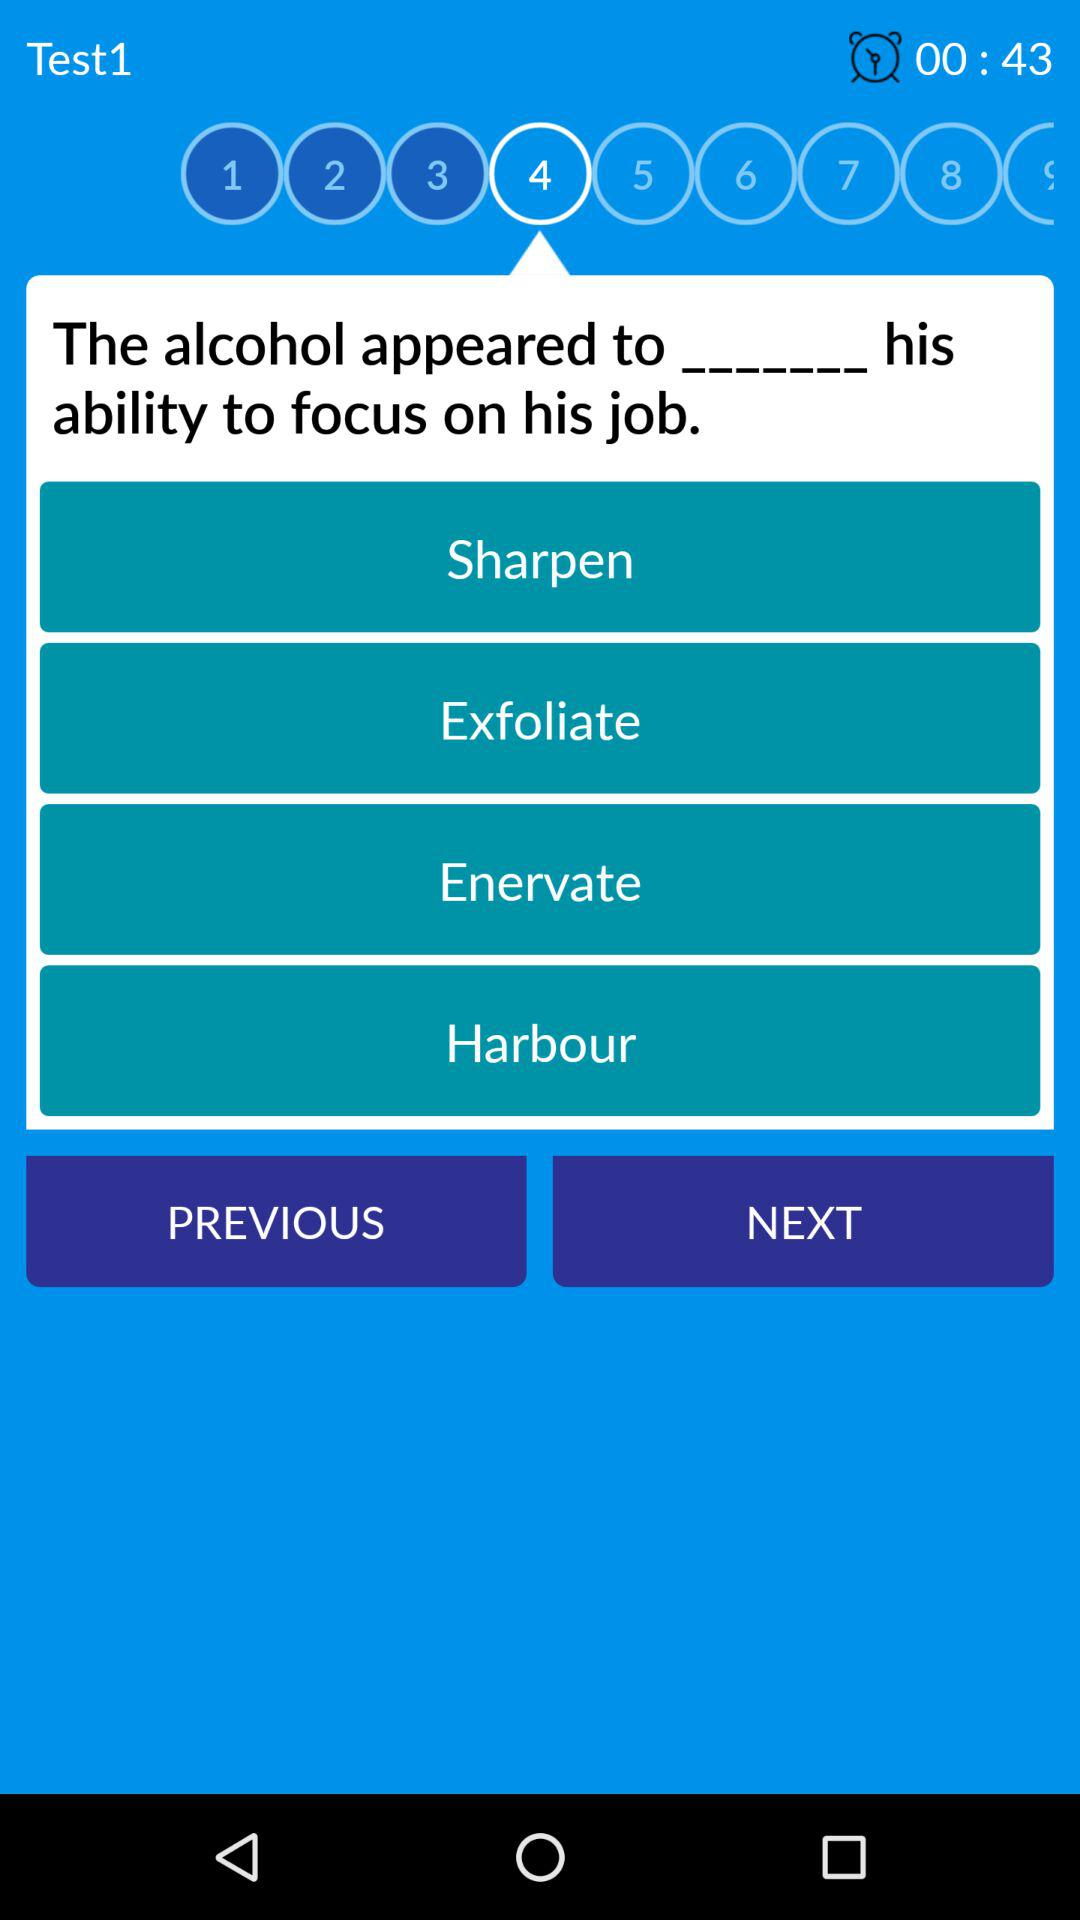What is the number of the test? The number is "Test1". 